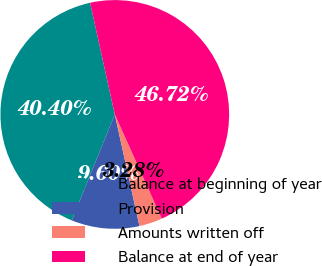<chart> <loc_0><loc_0><loc_500><loc_500><pie_chart><fcel>Balance at beginning of year<fcel>Provision<fcel>Amounts written off<fcel>Balance at end of year<nl><fcel>40.4%<fcel>9.6%<fcel>3.28%<fcel>46.72%<nl></chart> 